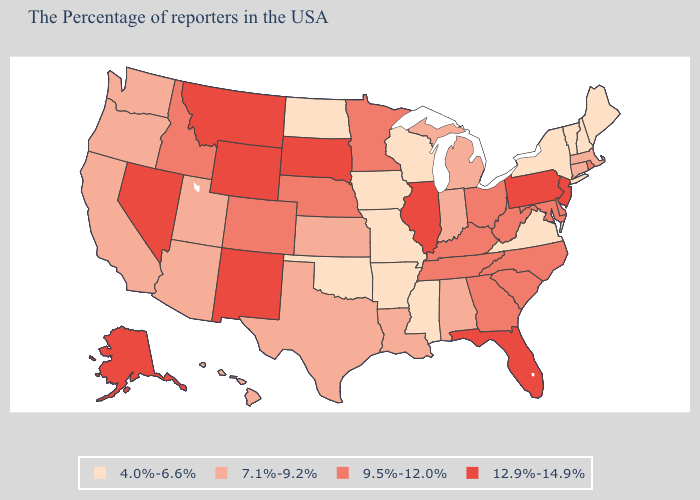Name the states that have a value in the range 9.5%-12.0%?
Keep it brief. Rhode Island, Delaware, Maryland, North Carolina, South Carolina, West Virginia, Ohio, Georgia, Kentucky, Tennessee, Minnesota, Nebraska, Colorado, Idaho. Which states have the lowest value in the MidWest?
Be succinct. Wisconsin, Missouri, Iowa, North Dakota. Which states have the highest value in the USA?
Give a very brief answer. New Jersey, Pennsylvania, Florida, Illinois, South Dakota, Wyoming, New Mexico, Montana, Nevada, Alaska. What is the highest value in states that border Pennsylvania?
Keep it brief. 12.9%-14.9%. What is the value of Kansas?
Keep it brief. 7.1%-9.2%. What is the value of Utah?
Concise answer only. 7.1%-9.2%. What is the value of Montana?
Write a very short answer. 12.9%-14.9%. Name the states that have a value in the range 9.5%-12.0%?
Short answer required. Rhode Island, Delaware, Maryland, North Carolina, South Carolina, West Virginia, Ohio, Georgia, Kentucky, Tennessee, Minnesota, Nebraska, Colorado, Idaho. What is the value of Wisconsin?
Give a very brief answer. 4.0%-6.6%. Does Connecticut have the highest value in the Northeast?
Quick response, please. No. What is the value of Kansas?
Keep it brief. 7.1%-9.2%. Name the states that have a value in the range 9.5%-12.0%?
Quick response, please. Rhode Island, Delaware, Maryland, North Carolina, South Carolina, West Virginia, Ohio, Georgia, Kentucky, Tennessee, Minnesota, Nebraska, Colorado, Idaho. Which states hav the highest value in the Northeast?
Be succinct. New Jersey, Pennsylvania. What is the value of Iowa?
Give a very brief answer. 4.0%-6.6%. 